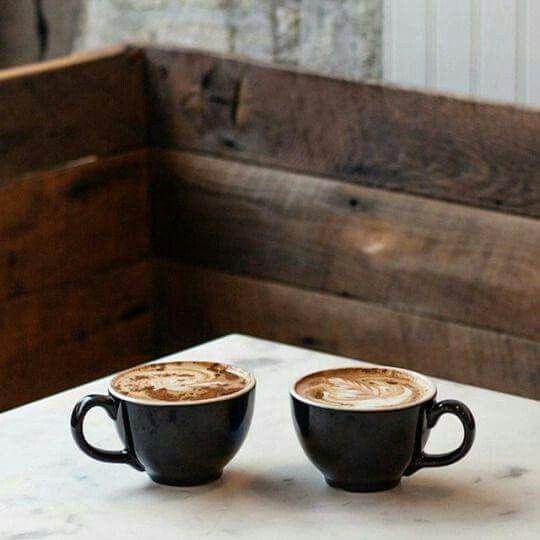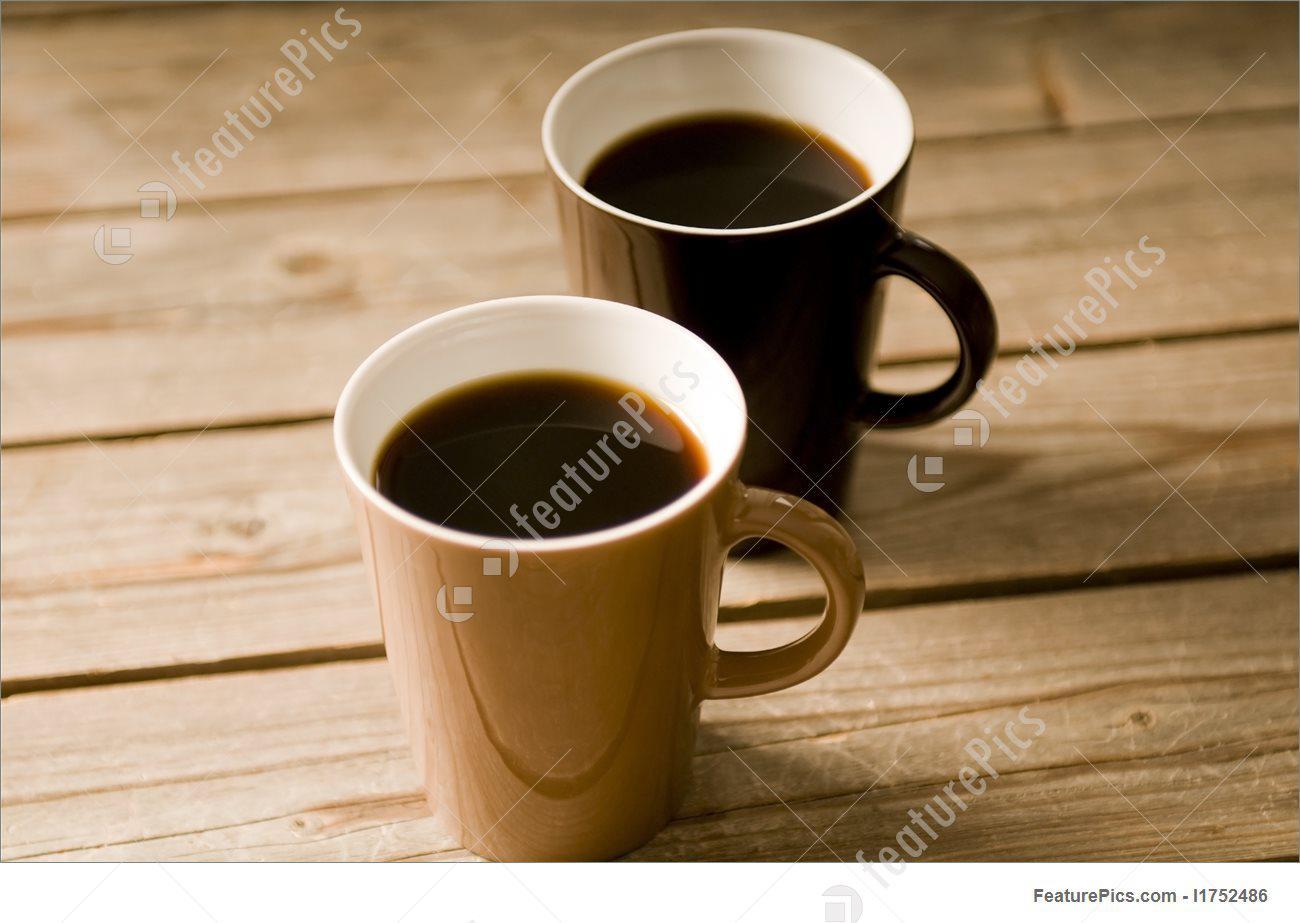The first image is the image on the left, the second image is the image on the right. Assess this claim about the two images: "The two white cups in the image on the left are sitting in saucers.". Correct or not? Answer yes or no. No. 